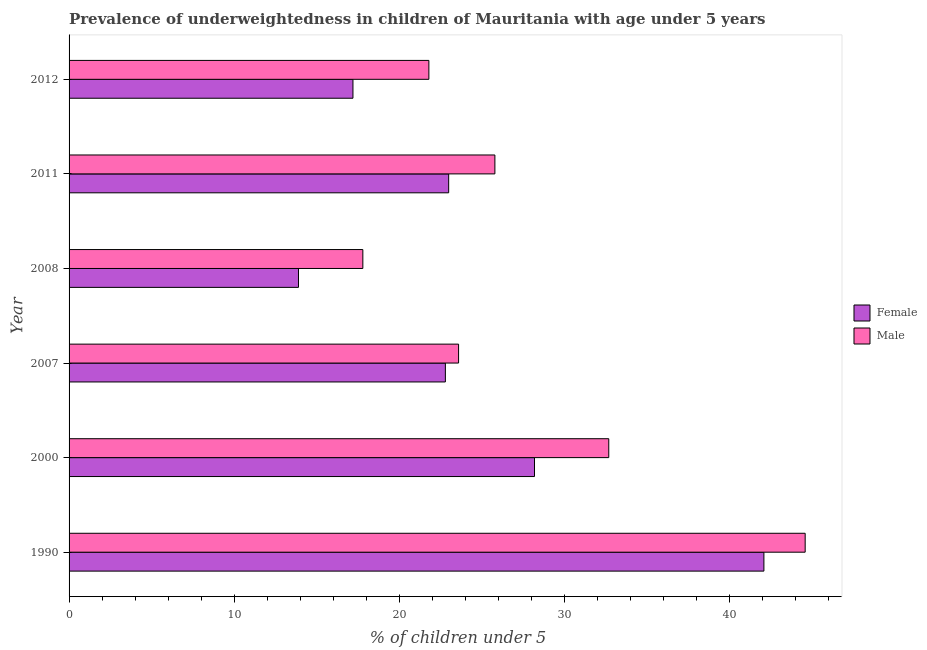How many different coloured bars are there?
Offer a terse response. 2. How many groups of bars are there?
Your answer should be compact. 6. Are the number of bars per tick equal to the number of legend labels?
Provide a short and direct response. Yes. Are the number of bars on each tick of the Y-axis equal?
Give a very brief answer. Yes. What is the percentage of underweighted male children in 2012?
Keep it short and to the point. 21.8. Across all years, what is the maximum percentage of underweighted male children?
Your answer should be very brief. 44.6. Across all years, what is the minimum percentage of underweighted female children?
Your response must be concise. 13.9. In which year was the percentage of underweighted female children maximum?
Keep it short and to the point. 1990. What is the total percentage of underweighted female children in the graph?
Keep it short and to the point. 147.2. What is the difference between the percentage of underweighted male children in 1990 and that in 2008?
Provide a succinct answer. 26.8. What is the difference between the percentage of underweighted male children in 1990 and the percentage of underweighted female children in 2008?
Your answer should be very brief. 30.7. What is the average percentage of underweighted male children per year?
Offer a very short reply. 27.72. In the year 2007, what is the difference between the percentage of underweighted male children and percentage of underweighted female children?
Your answer should be very brief. 0.8. What is the ratio of the percentage of underweighted male children in 2007 to that in 2008?
Provide a short and direct response. 1.33. Is the percentage of underweighted male children in 2011 less than that in 2012?
Your answer should be compact. No. Is the difference between the percentage of underweighted female children in 1990 and 2008 greater than the difference between the percentage of underweighted male children in 1990 and 2008?
Your answer should be very brief. Yes. What is the difference between the highest and the lowest percentage of underweighted male children?
Keep it short and to the point. 26.8. How many bars are there?
Your answer should be compact. 12. How many years are there in the graph?
Provide a short and direct response. 6. What is the difference between two consecutive major ticks on the X-axis?
Offer a terse response. 10. Does the graph contain any zero values?
Keep it short and to the point. No. Does the graph contain grids?
Ensure brevity in your answer.  No. Where does the legend appear in the graph?
Make the answer very short. Center right. How are the legend labels stacked?
Your response must be concise. Vertical. What is the title of the graph?
Make the answer very short. Prevalence of underweightedness in children of Mauritania with age under 5 years. What is the label or title of the X-axis?
Your answer should be very brief.  % of children under 5. What is the label or title of the Y-axis?
Ensure brevity in your answer.  Year. What is the  % of children under 5 in Female in 1990?
Ensure brevity in your answer.  42.1. What is the  % of children under 5 of Male in 1990?
Offer a very short reply. 44.6. What is the  % of children under 5 in Female in 2000?
Keep it short and to the point. 28.2. What is the  % of children under 5 of Male in 2000?
Offer a terse response. 32.7. What is the  % of children under 5 in Female in 2007?
Give a very brief answer. 22.8. What is the  % of children under 5 in Male in 2007?
Provide a succinct answer. 23.6. What is the  % of children under 5 in Female in 2008?
Offer a terse response. 13.9. What is the  % of children under 5 of Male in 2008?
Offer a terse response. 17.8. What is the  % of children under 5 of Male in 2011?
Your answer should be very brief. 25.8. What is the  % of children under 5 in Female in 2012?
Give a very brief answer. 17.2. What is the  % of children under 5 in Male in 2012?
Give a very brief answer. 21.8. Across all years, what is the maximum  % of children under 5 of Female?
Your answer should be very brief. 42.1. Across all years, what is the maximum  % of children under 5 of Male?
Your answer should be very brief. 44.6. Across all years, what is the minimum  % of children under 5 in Female?
Offer a very short reply. 13.9. Across all years, what is the minimum  % of children under 5 of Male?
Provide a succinct answer. 17.8. What is the total  % of children under 5 in Female in the graph?
Your answer should be compact. 147.2. What is the total  % of children under 5 in Male in the graph?
Provide a succinct answer. 166.3. What is the difference between the  % of children under 5 of Female in 1990 and that in 2000?
Provide a short and direct response. 13.9. What is the difference between the  % of children under 5 in Male in 1990 and that in 2000?
Offer a very short reply. 11.9. What is the difference between the  % of children under 5 of Female in 1990 and that in 2007?
Offer a very short reply. 19.3. What is the difference between the  % of children under 5 of Female in 1990 and that in 2008?
Offer a terse response. 28.2. What is the difference between the  % of children under 5 of Male in 1990 and that in 2008?
Your answer should be compact. 26.8. What is the difference between the  % of children under 5 of Male in 1990 and that in 2011?
Give a very brief answer. 18.8. What is the difference between the  % of children under 5 of Female in 1990 and that in 2012?
Provide a succinct answer. 24.9. What is the difference between the  % of children under 5 in Male in 1990 and that in 2012?
Your answer should be compact. 22.8. What is the difference between the  % of children under 5 in Female in 2000 and that in 2012?
Ensure brevity in your answer.  11. What is the difference between the  % of children under 5 in Male in 2007 and that in 2008?
Provide a short and direct response. 5.8. What is the difference between the  % of children under 5 in Female in 2007 and that in 2012?
Ensure brevity in your answer.  5.6. What is the difference between the  % of children under 5 in Male in 2008 and that in 2011?
Provide a short and direct response. -8. What is the difference between the  % of children under 5 of Female in 2008 and that in 2012?
Offer a very short reply. -3.3. What is the difference between the  % of children under 5 in Male in 2008 and that in 2012?
Ensure brevity in your answer.  -4. What is the difference between the  % of children under 5 of Male in 2011 and that in 2012?
Make the answer very short. 4. What is the difference between the  % of children under 5 in Female in 1990 and the  % of children under 5 in Male in 2008?
Offer a very short reply. 24.3. What is the difference between the  % of children under 5 in Female in 1990 and the  % of children under 5 in Male in 2012?
Provide a succinct answer. 20.3. What is the difference between the  % of children under 5 of Female in 2000 and the  % of children under 5 of Male in 2008?
Offer a terse response. 10.4. What is the difference between the  % of children under 5 of Female in 2000 and the  % of children under 5 of Male in 2011?
Your answer should be compact. 2.4. What is the difference between the  % of children under 5 in Female in 2000 and the  % of children under 5 in Male in 2012?
Ensure brevity in your answer.  6.4. What is the difference between the  % of children under 5 of Female in 2007 and the  % of children under 5 of Male in 2008?
Ensure brevity in your answer.  5. What is the difference between the  % of children under 5 in Female in 2007 and the  % of children under 5 in Male in 2011?
Keep it short and to the point. -3. What is the difference between the  % of children under 5 of Female in 2007 and the  % of children under 5 of Male in 2012?
Make the answer very short. 1. What is the difference between the  % of children under 5 in Female in 2008 and the  % of children under 5 in Male in 2011?
Ensure brevity in your answer.  -11.9. What is the difference between the  % of children under 5 of Female in 2008 and the  % of children under 5 of Male in 2012?
Offer a terse response. -7.9. What is the average  % of children under 5 in Female per year?
Provide a succinct answer. 24.53. What is the average  % of children under 5 of Male per year?
Offer a terse response. 27.72. In the year 2007, what is the difference between the  % of children under 5 of Female and  % of children under 5 of Male?
Offer a very short reply. -0.8. In the year 2011, what is the difference between the  % of children under 5 of Female and  % of children under 5 of Male?
Provide a short and direct response. -2.8. What is the ratio of the  % of children under 5 in Female in 1990 to that in 2000?
Your answer should be compact. 1.49. What is the ratio of the  % of children under 5 of Male in 1990 to that in 2000?
Give a very brief answer. 1.36. What is the ratio of the  % of children under 5 of Female in 1990 to that in 2007?
Offer a terse response. 1.85. What is the ratio of the  % of children under 5 in Male in 1990 to that in 2007?
Ensure brevity in your answer.  1.89. What is the ratio of the  % of children under 5 in Female in 1990 to that in 2008?
Ensure brevity in your answer.  3.03. What is the ratio of the  % of children under 5 of Male in 1990 to that in 2008?
Offer a very short reply. 2.51. What is the ratio of the  % of children under 5 in Female in 1990 to that in 2011?
Ensure brevity in your answer.  1.83. What is the ratio of the  % of children under 5 in Male in 1990 to that in 2011?
Offer a very short reply. 1.73. What is the ratio of the  % of children under 5 in Female in 1990 to that in 2012?
Give a very brief answer. 2.45. What is the ratio of the  % of children under 5 of Male in 1990 to that in 2012?
Give a very brief answer. 2.05. What is the ratio of the  % of children under 5 of Female in 2000 to that in 2007?
Keep it short and to the point. 1.24. What is the ratio of the  % of children under 5 of Male in 2000 to that in 2007?
Give a very brief answer. 1.39. What is the ratio of the  % of children under 5 of Female in 2000 to that in 2008?
Make the answer very short. 2.03. What is the ratio of the  % of children under 5 of Male in 2000 to that in 2008?
Give a very brief answer. 1.84. What is the ratio of the  % of children under 5 in Female in 2000 to that in 2011?
Make the answer very short. 1.23. What is the ratio of the  % of children under 5 of Male in 2000 to that in 2011?
Keep it short and to the point. 1.27. What is the ratio of the  % of children under 5 in Female in 2000 to that in 2012?
Your answer should be compact. 1.64. What is the ratio of the  % of children under 5 in Male in 2000 to that in 2012?
Give a very brief answer. 1.5. What is the ratio of the  % of children under 5 in Female in 2007 to that in 2008?
Keep it short and to the point. 1.64. What is the ratio of the  % of children under 5 of Male in 2007 to that in 2008?
Ensure brevity in your answer.  1.33. What is the ratio of the  % of children under 5 of Male in 2007 to that in 2011?
Give a very brief answer. 0.91. What is the ratio of the  % of children under 5 in Female in 2007 to that in 2012?
Keep it short and to the point. 1.33. What is the ratio of the  % of children under 5 in Male in 2007 to that in 2012?
Your response must be concise. 1.08. What is the ratio of the  % of children under 5 in Female in 2008 to that in 2011?
Provide a short and direct response. 0.6. What is the ratio of the  % of children under 5 in Male in 2008 to that in 2011?
Your answer should be very brief. 0.69. What is the ratio of the  % of children under 5 of Female in 2008 to that in 2012?
Your answer should be compact. 0.81. What is the ratio of the  % of children under 5 in Male in 2008 to that in 2012?
Give a very brief answer. 0.82. What is the ratio of the  % of children under 5 in Female in 2011 to that in 2012?
Give a very brief answer. 1.34. What is the ratio of the  % of children under 5 in Male in 2011 to that in 2012?
Make the answer very short. 1.18. What is the difference between the highest and the lowest  % of children under 5 of Female?
Provide a succinct answer. 28.2. What is the difference between the highest and the lowest  % of children under 5 in Male?
Your answer should be compact. 26.8. 